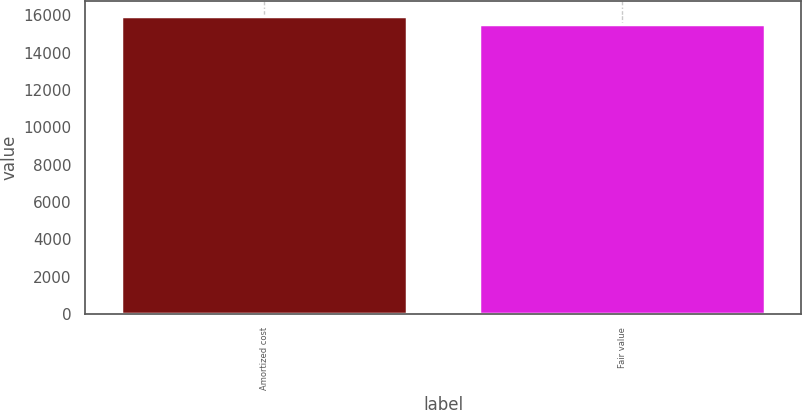Convert chart to OTSL. <chart><loc_0><loc_0><loc_500><loc_500><bar_chart><fcel>Amortized cost<fcel>Fair value<nl><fcel>15948<fcel>15563<nl></chart> 